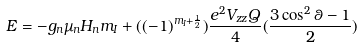Convert formula to latex. <formula><loc_0><loc_0><loc_500><loc_500>E = - g _ { n } \mu _ { n } H _ { n } m _ { I } + ( ( - 1 ) ^ { m _ { I } + \frac { 1 } { 2 } } ) \frac { e ^ { 2 } V _ { z z } Q } { 4 } ( \frac { 3 \cos ^ { 2 } \theta - 1 } { 2 } )</formula> 